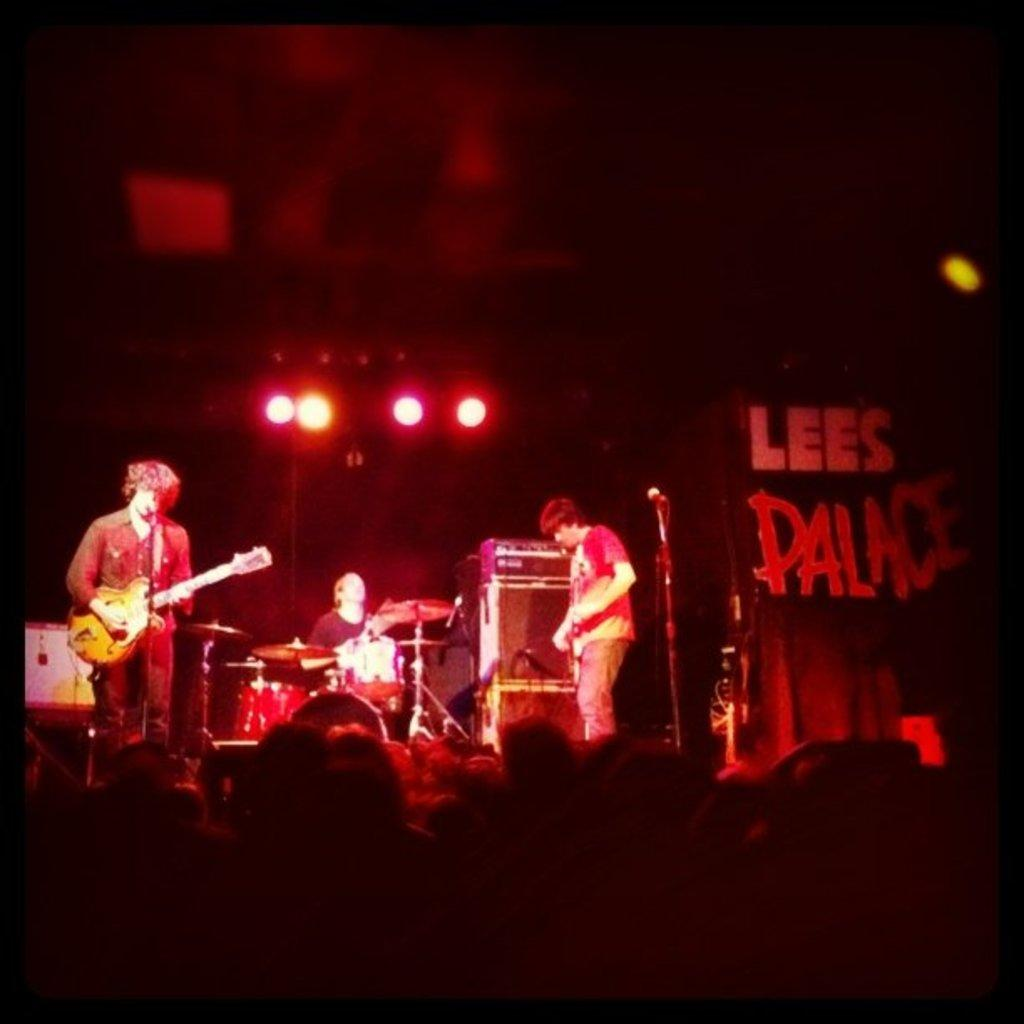How many people are in the image? There are three persons in the image. What are the people in the image doing? Each person is playing a different musical instrument. What type of bushes can be seen in the background of the image? There is no background or bushes present in the image; it only features three persons playing musical instruments. What type of legal advice can be sought from the persons in the image? There is no lawyer or legal advice present in the image; it only features three persons playing musical instruments. 